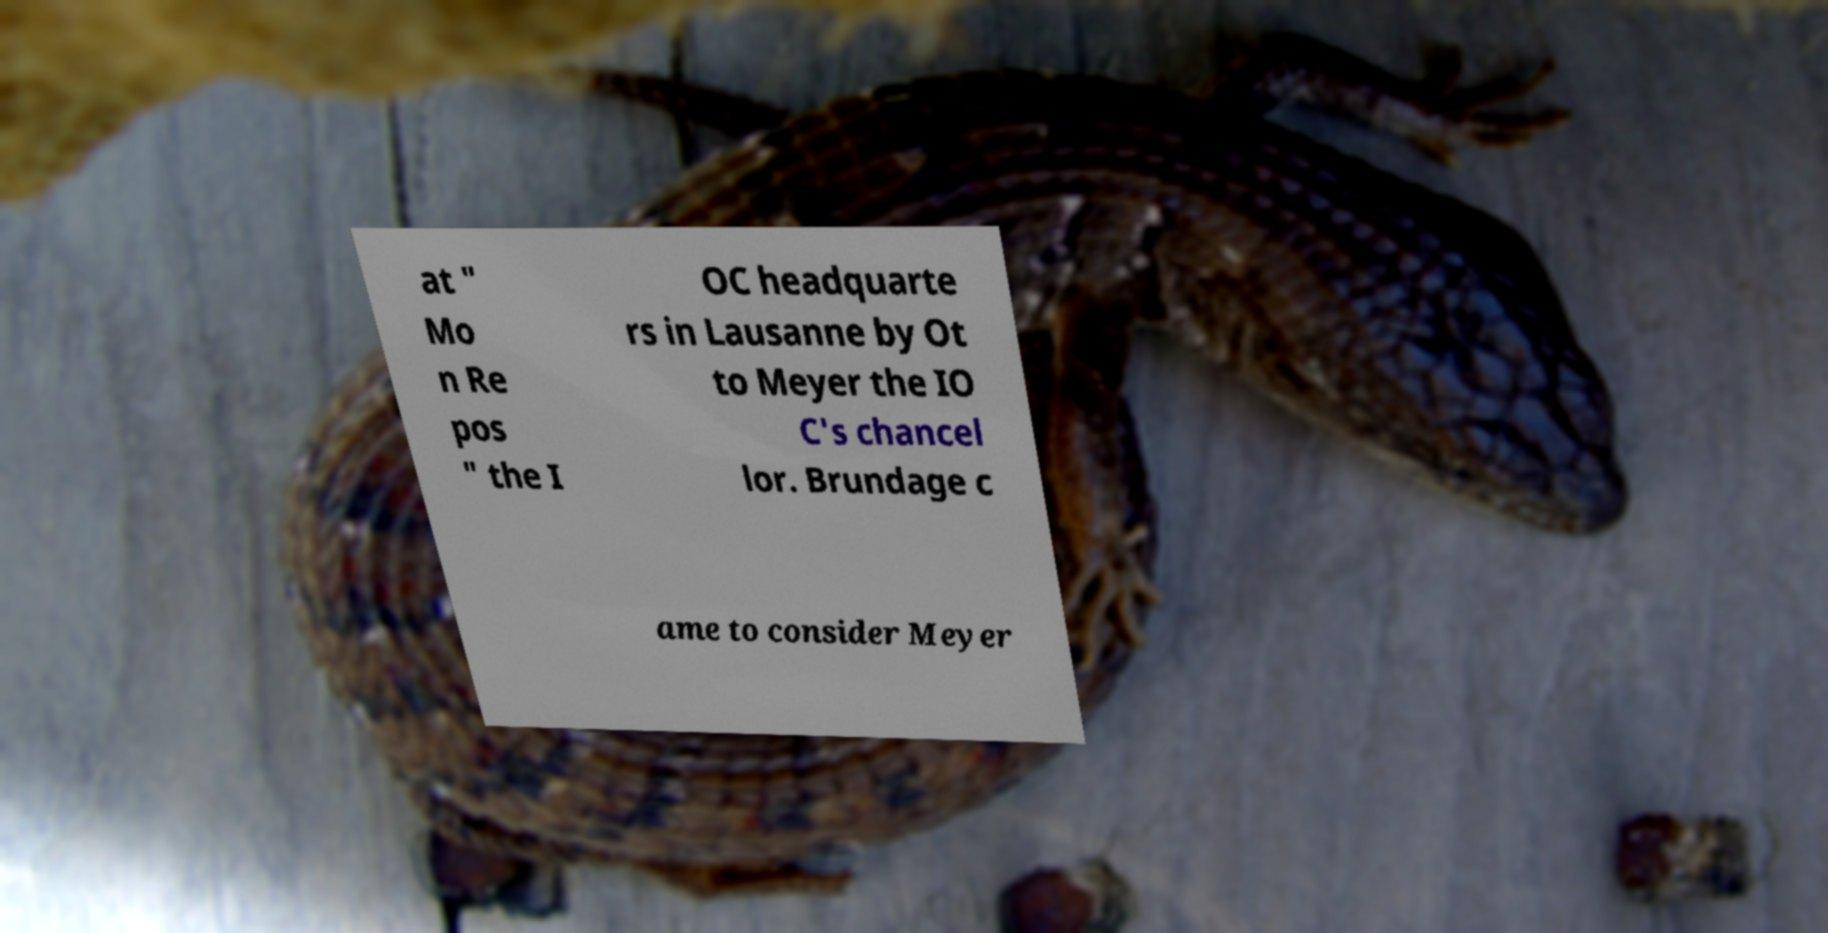Could you extract and type out the text from this image? at " Mo n Re pos " the I OC headquarte rs in Lausanne by Ot to Meyer the IO C's chancel lor. Brundage c ame to consider Meyer 